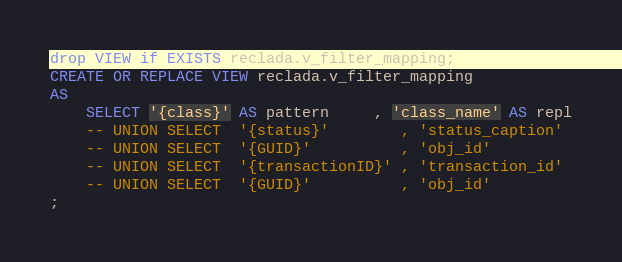Convert code to text. <code><loc_0><loc_0><loc_500><loc_500><_SQL_>drop VIEW if EXISTS reclada.v_filter_mapping;
CREATE OR REPLACE VIEW reclada.v_filter_mapping
AS
    SELECT '{class}' AS pattern     , 'class_name' AS repl
    -- UNION SELECT  '{status}'        , 'status_caption' 
    -- UNION SELECT  '{GUID}'          , 'obj_id' 
    -- UNION SELECT  '{transactionID}' , 'transaction_id' 
    -- UNION SELECT  '{GUID}'          , 'obj_id' 
;
</code> 